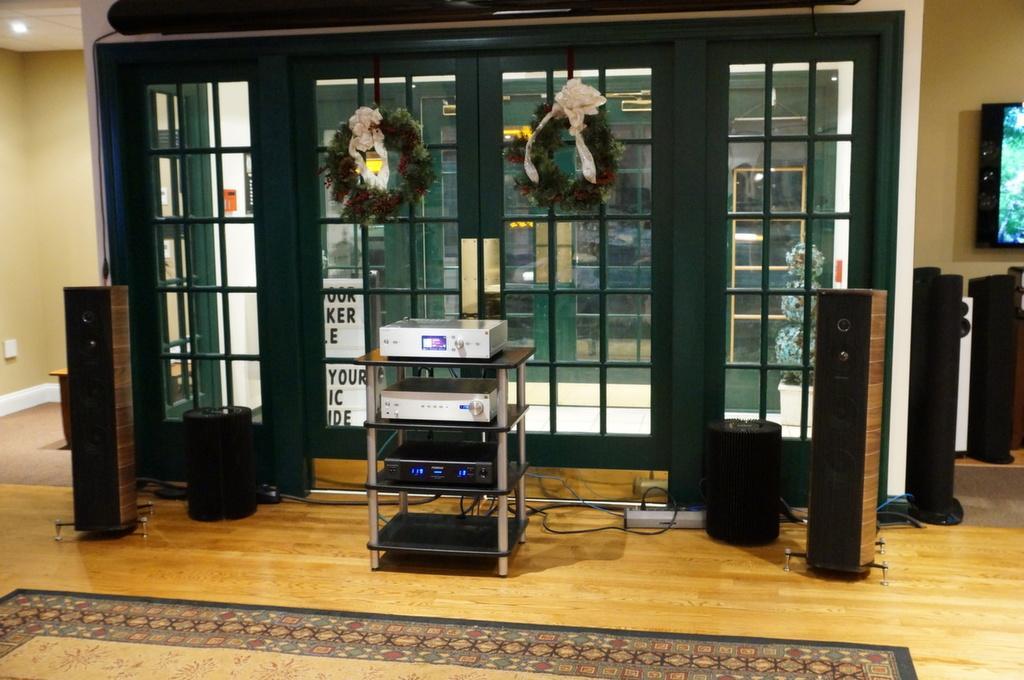Can you describe this image briefly? In the foreground I can see a table, DVD player, speakers and so on on the floor. In the background I can see a wall, windows, garlands and a TV. This image is taken in a hall. 